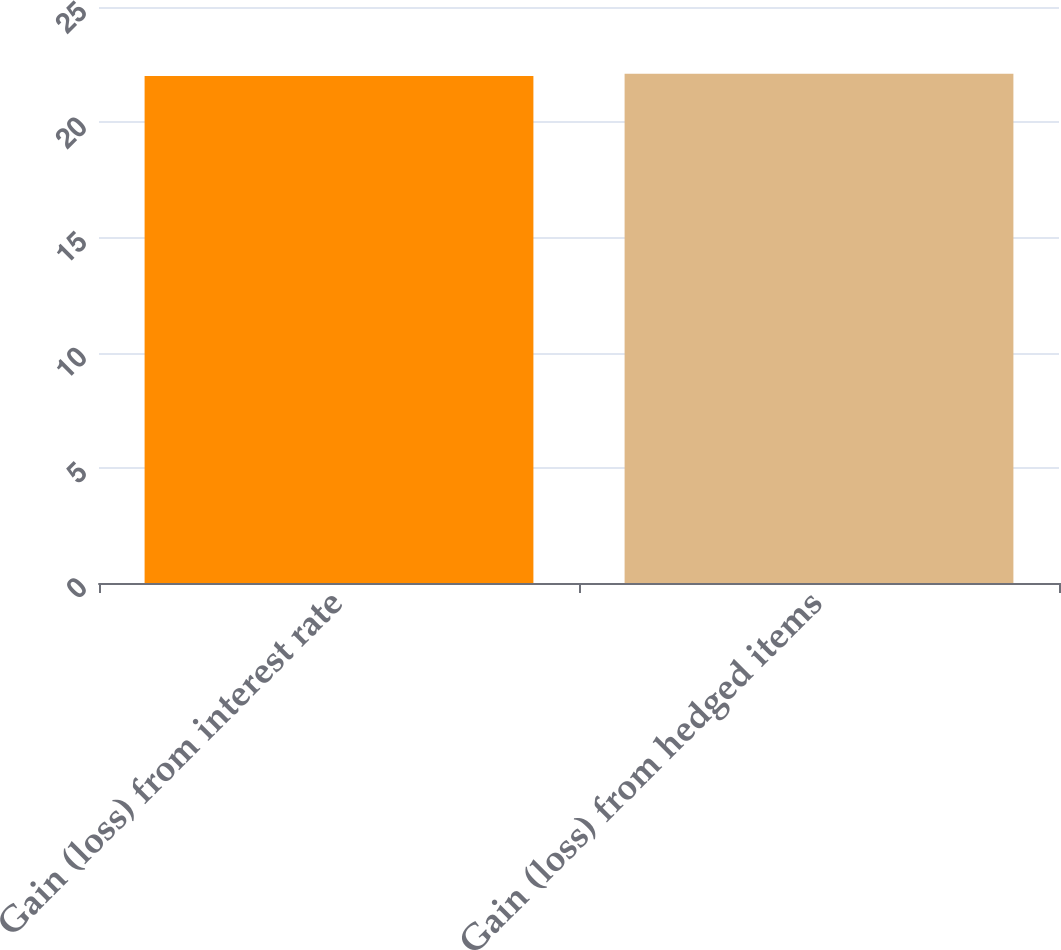Convert chart to OTSL. <chart><loc_0><loc_0><loc_500><loc_500><bar_chart><fcel>Gain (loss) from interest rate<fcel>Gain (loss) from hedged items<nl><fcel>22<fcel>22.1<nl></chart> 